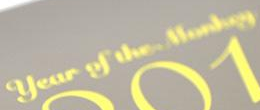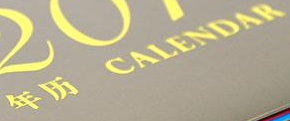What text appears in these images from left to right, separated by a semicolon? #; # 